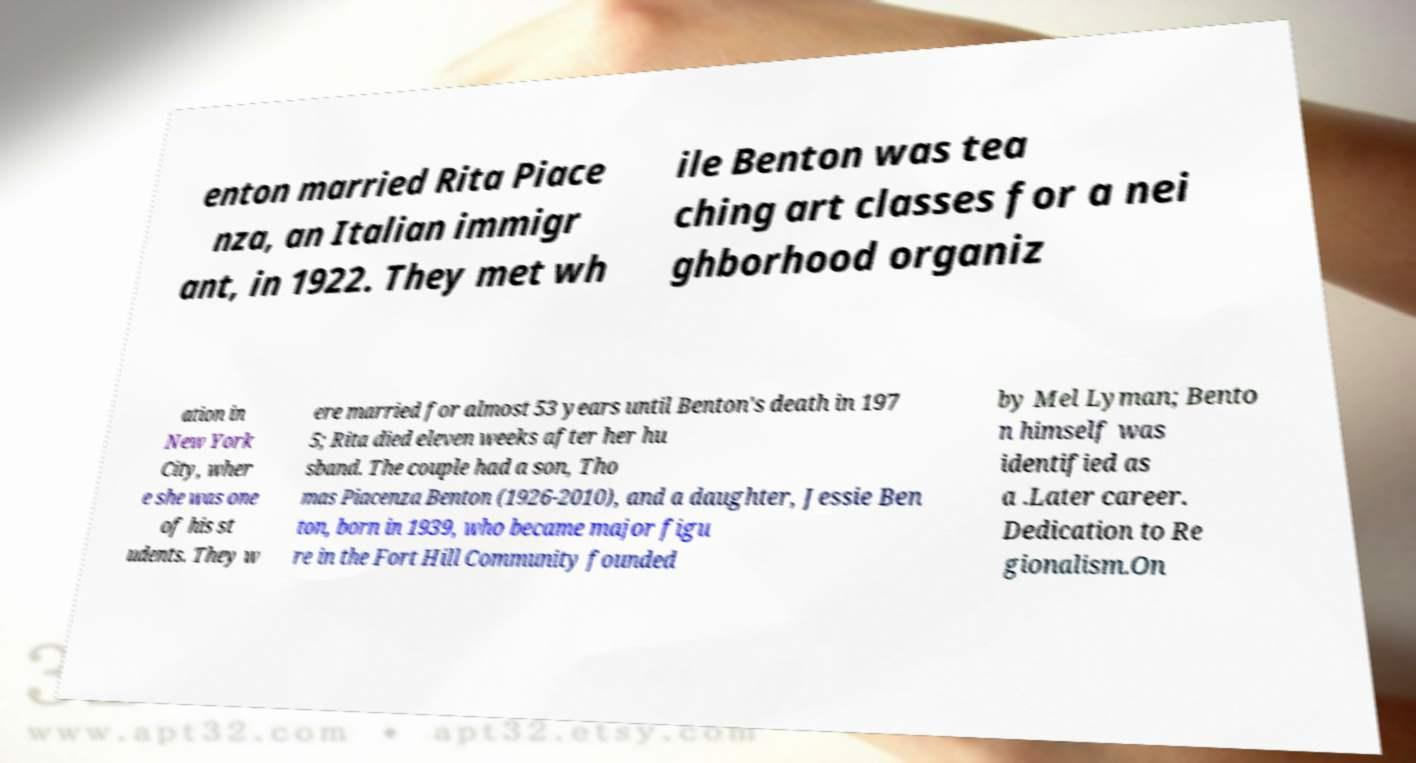What messages or text are displayed in this image? I need them in a readable, typed format. enton married Rita Piace nza, an Italian immigr ant, in 1922. They met wh ile Benton was tea ching art classes for a nei ghborhood organiz ation in New York City, wher e she was one of his st udents. They w ere married for almost 53 years until Benton's death in 197 5; Rita died eleven weeks after her hu sband. The couple had a son, Tho mas Piacenza Benton (1926-2010), and a daughter, Jessie Ben ton, born in 1939, who became major figu re in the Fort Hill Community founded by Mel Lyman; Bento n himself was identified as a .Later career. Dedication to Re gionalism.On 